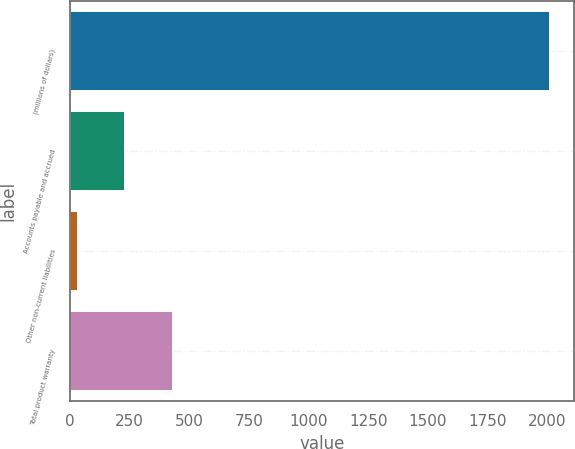Convert chart to OTSL. <chart><loc_0><loc_0><loc_500><loc_500><bar_chart><fcel>(millions of dollars)<fcel>Accounts payable and accrued<fcel>Other non-current liabilities<fcel>Total product warranty<nl><fcel>2013<fcel>232.17<fcel>34.3<fcel>430.04<nl></chart> 